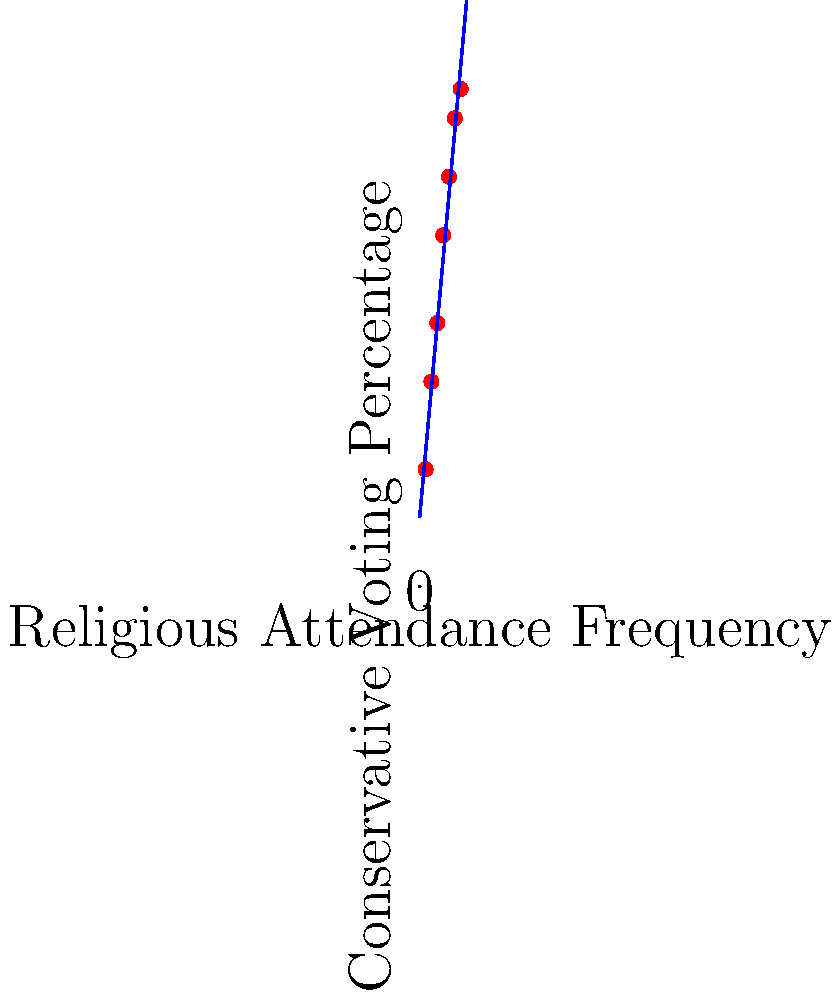Based on the scatter plot showing the relationship between religious attendance frequency and conservative voting patterns, what can be inferred about the correlation between these two variables? Calculate the approximate slope of the trend line and interpret its meaning in the context of the data. To analyze the correlation and calculate the slope:

1. Observe the scatter plot: The points show a clear upward trend from left to right, indicating a positive correlation between religious attendance frequency and conservative voting percentage.

2. Identify two points on the trend line for slope calculation:
   - Point 1: (1, 23)
   - Point 2: (7, 89)

3. Calculate the slope using the formula:
   $$ \text{Slope} = \frac{y_2 - y_1}{x_2 - x_1} = \frac{89 - 23}{7 - 1} = \frac{66}{6} = 11 $$

4. Interpret the slope: For each unit increase in religious attendance frequency, there is an approximate 11 percentage point increase in conservative voting percentage.

5. Overall interpretation: There is a strong positive correlation between religious attendance frequency and conservative voting patterns. As religious attendance increases, the likelihood of conservative voting also increases significantly.
Answer: Strong positive correlation; slope ≈ 11, indicating an 11 percentage point increase in conservative voting for each unit increase in religious attendance frequency. 